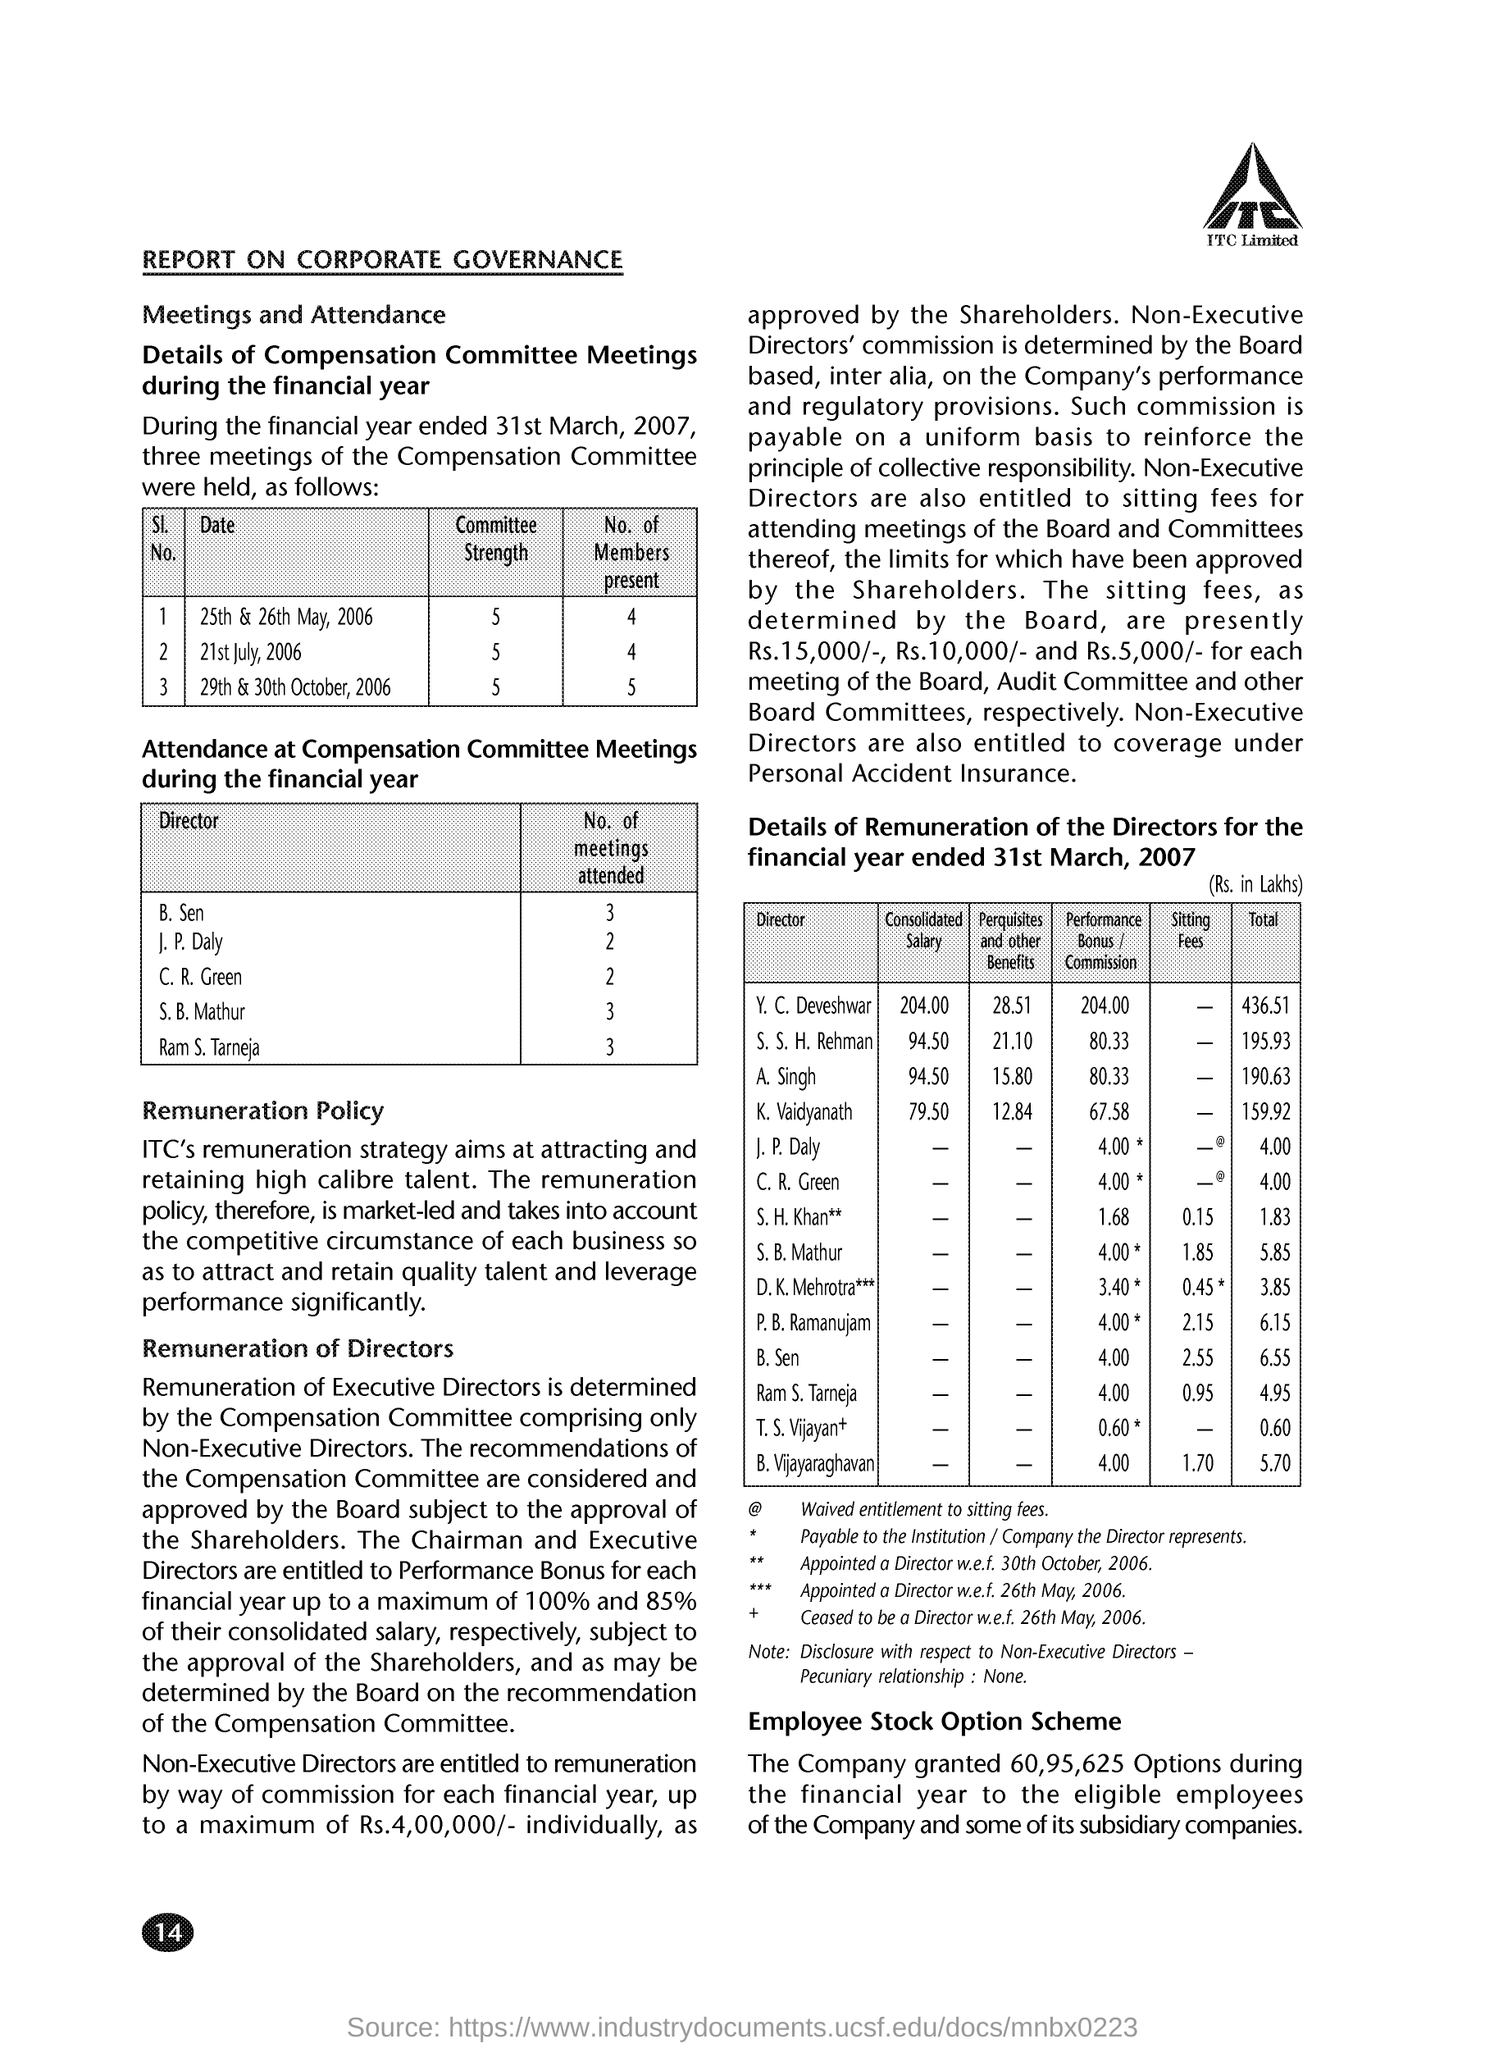How many no of meetings are attended by the director c.r.green ?
Offer a very short reply. 2. How many no of meetings are attended by the director b.sen ?
Give a very brief answer. 3. What is the committee strength on 21st july,2006 ?
Provide a succinct answer. 5. What is the committee strength on 29th &30th october ,2006?
Offer a very short reply. 5. 